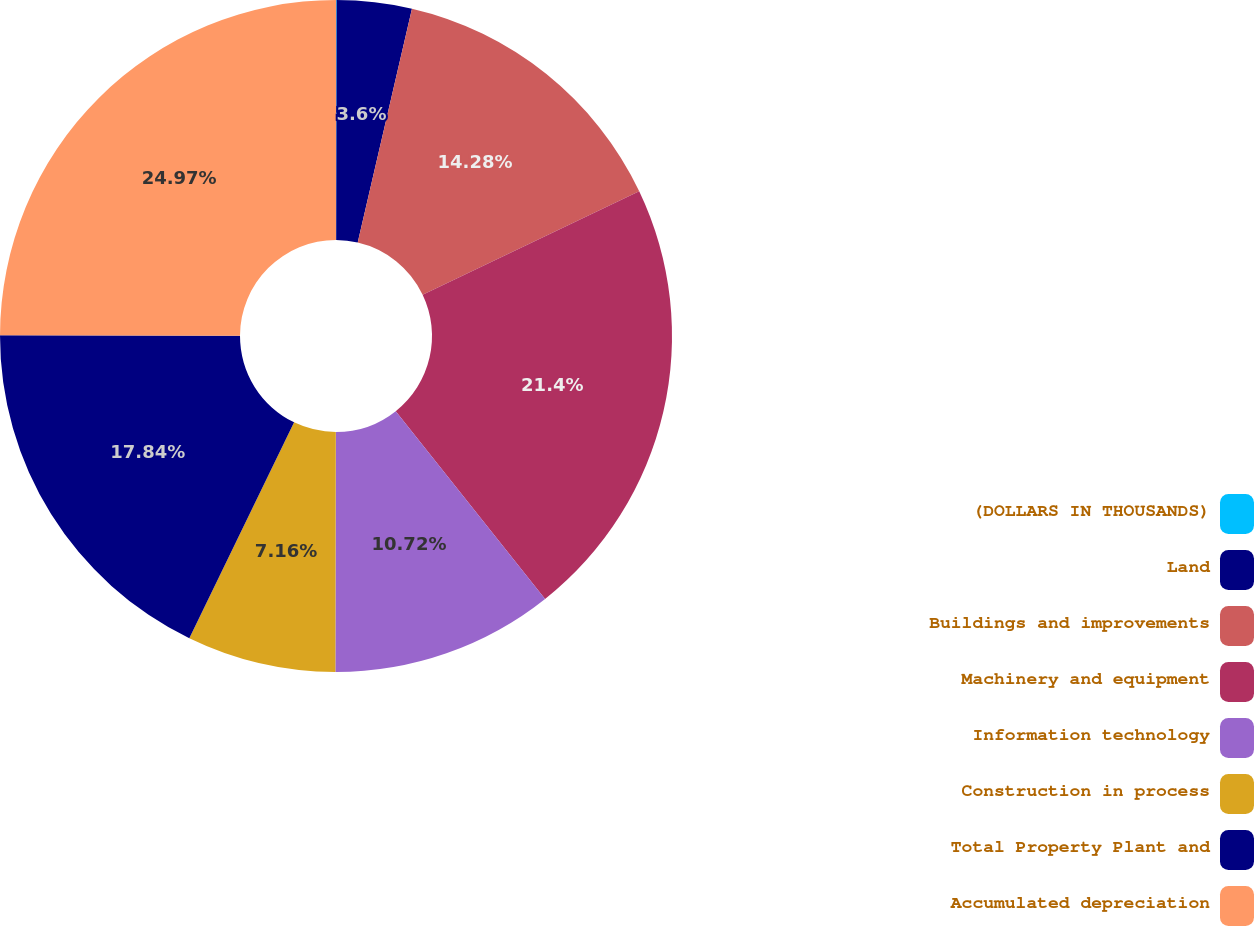Convert chart. <chart><loc_0><loc_0><loc_500><loc_500><pie_chart><fcel>(DOLLARS IN THOUSANDS)<fcel>Land<fcel>Buildings and improvements<fcel>Machinery and equipment<fcel>Information technology<fcel>Construction in process<fcel>Total Property Plant and<fcel>Accumulated depreciation<nl><fcel>0.03%<fcel>3.6%<fcel>14.28%<fcel>21.4%<fcel>10.72%<fcel>7.16%<fcel>17.84%<fcel>24.97%<nl></chart> 